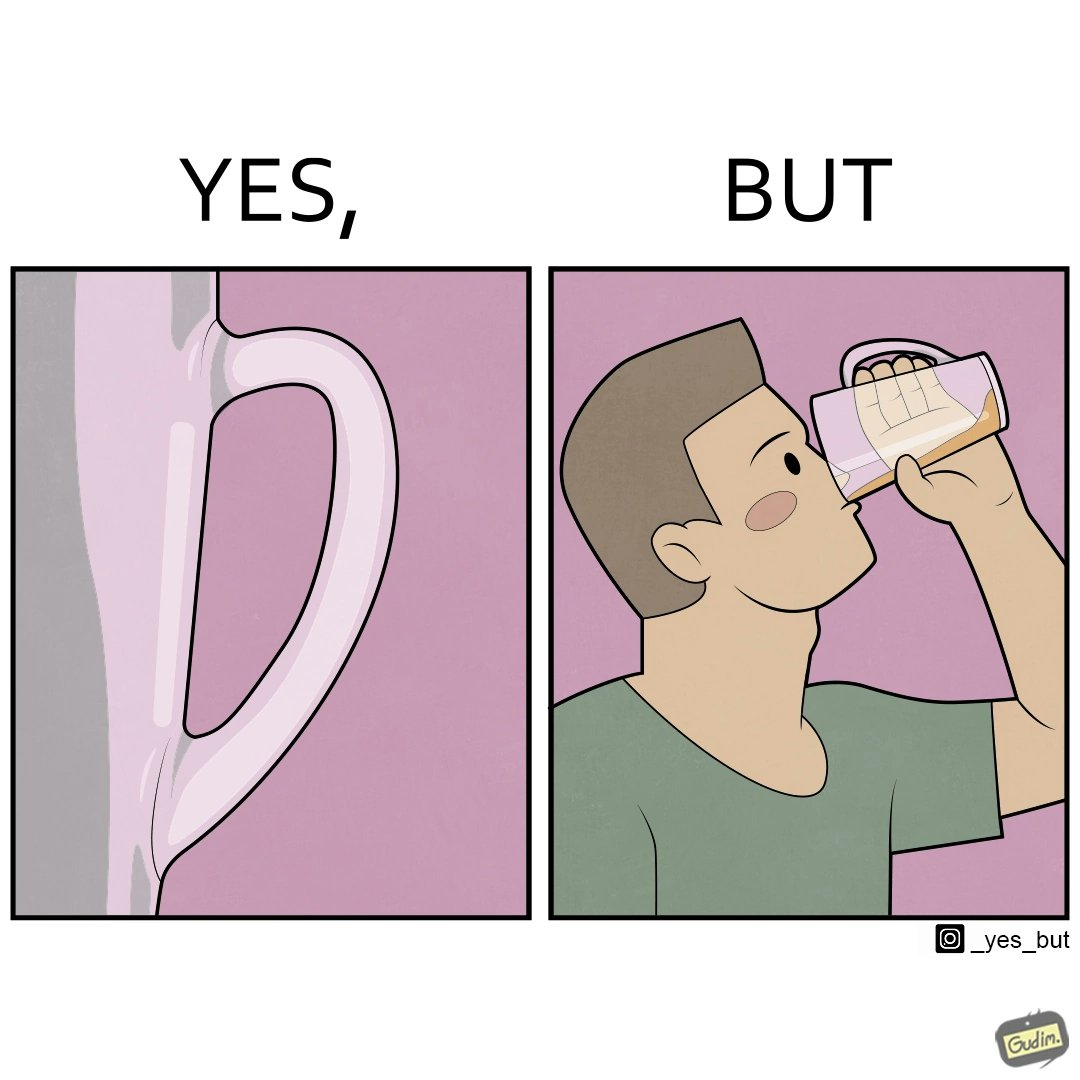Is there satirical content in this image? Yes, this image is satirical. 